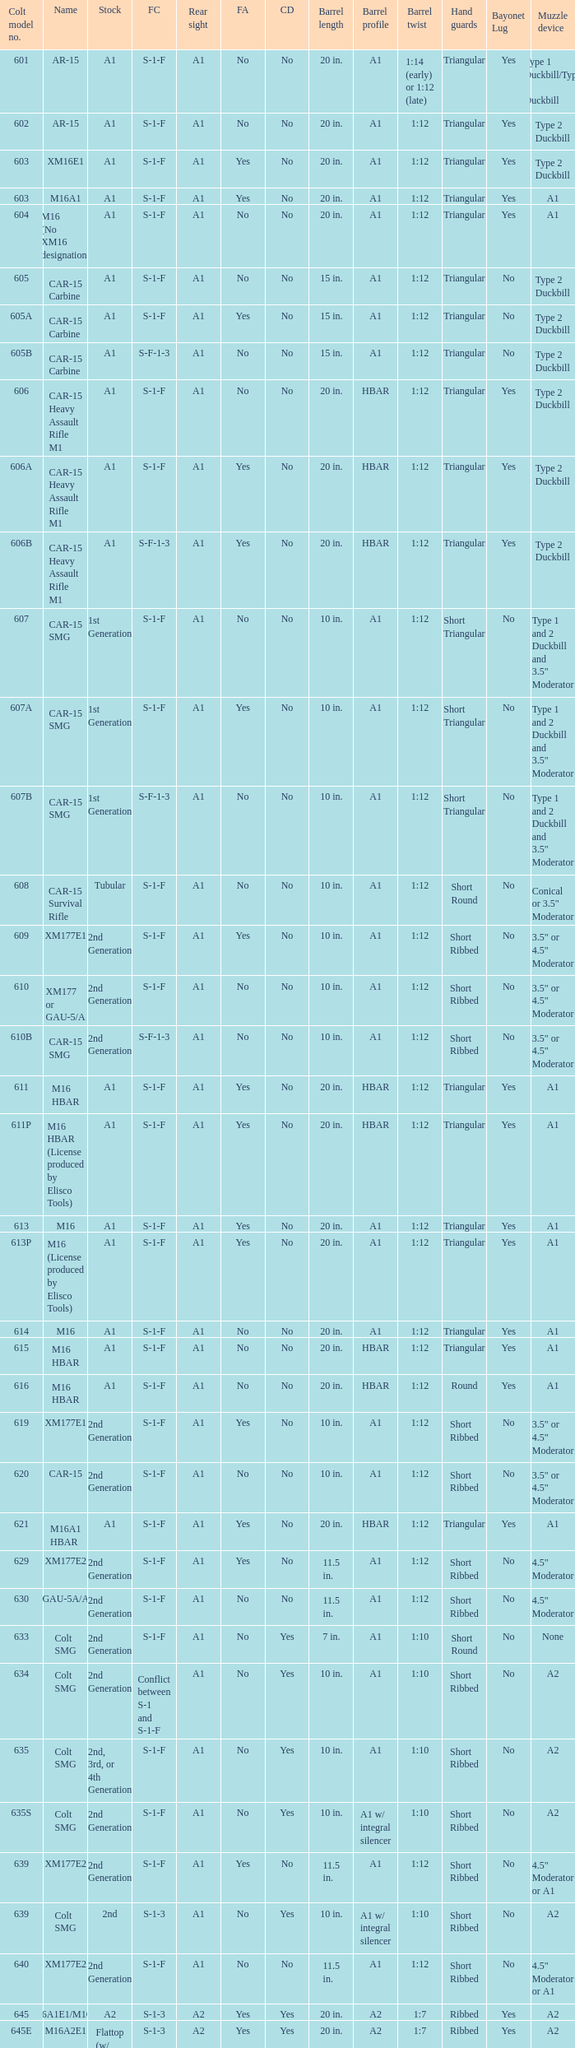What's the type of muzzle devices on the models with round hand guards? A1. 